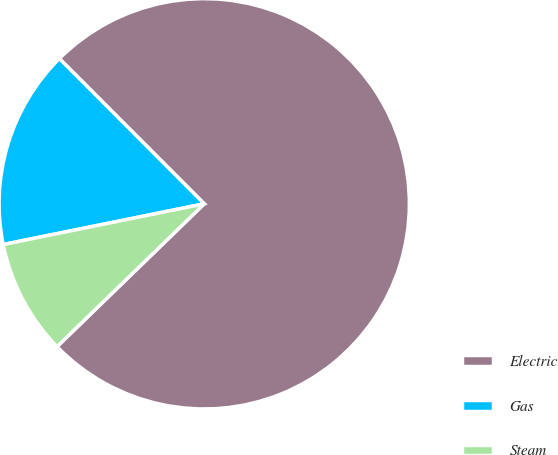Convert chart. <chart><loc_0><loc_0><loc_500><loc_500><pie_chart><fcel>Electric<fcel>Gas<fcel>Steam<nl><fcel>75.22%<fcel>15.7%<fcel>9.08%<nl></chart> 